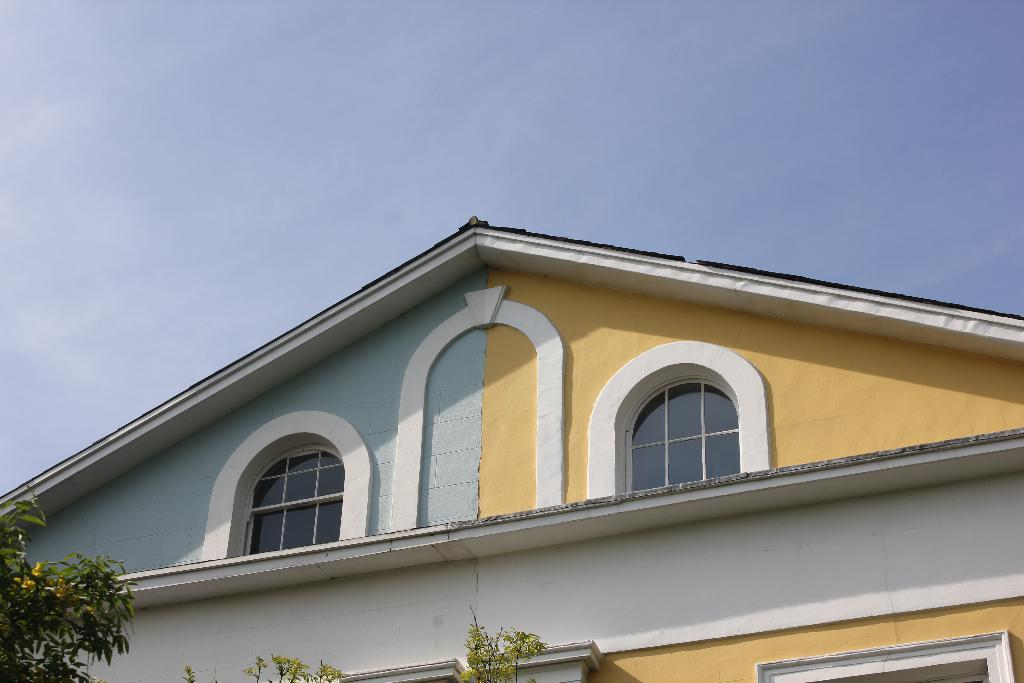What can be seen in the sky in the image? The sky is visible in the image, but no specific details about the sky can be determined from the provided facts. How is the building depicted in the image? The image includes a top and bottom view of a building. How many windows are visible on the building? The building has two windows. What type of vegetation is present in the image? There are leaves and a stem of a tree in the image. What type of pancake is being used to illuminate the building in the image? There is no pancake present in the image, and therefore no such activity can be observed. How does the lamp help the tree grow in the image? There is no lamp present in the image, and the tree's growth is not mentioned in the provided facts. 